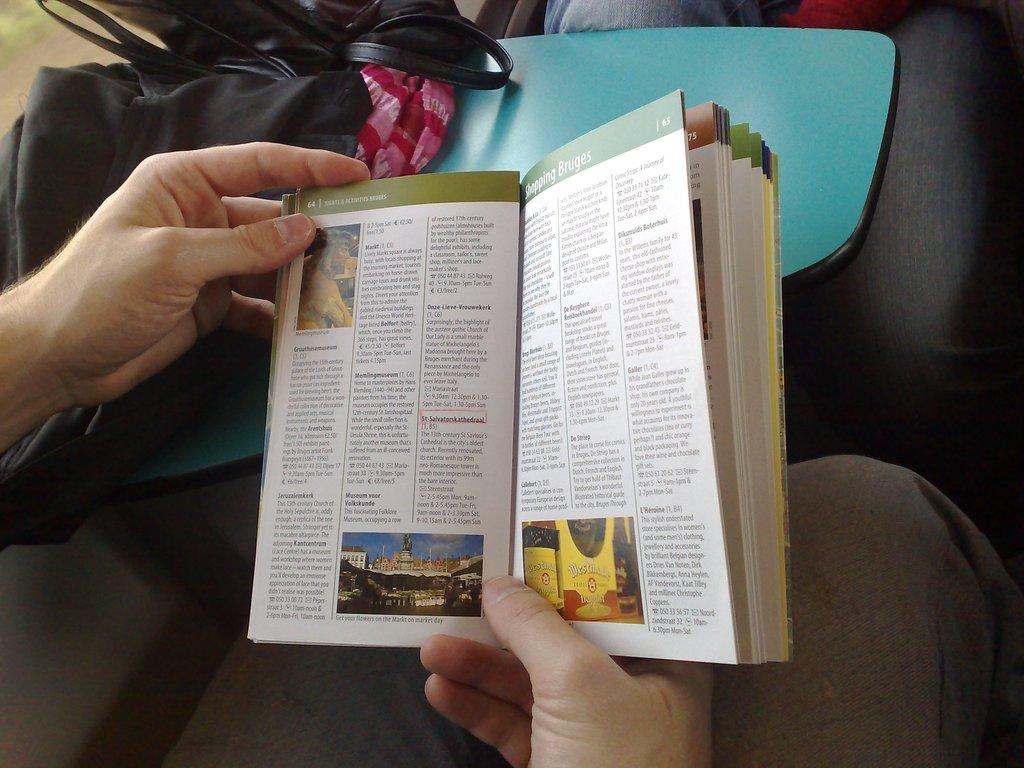<image>
Summarize the visual content of the image. A book with text and images is open to page 65. 